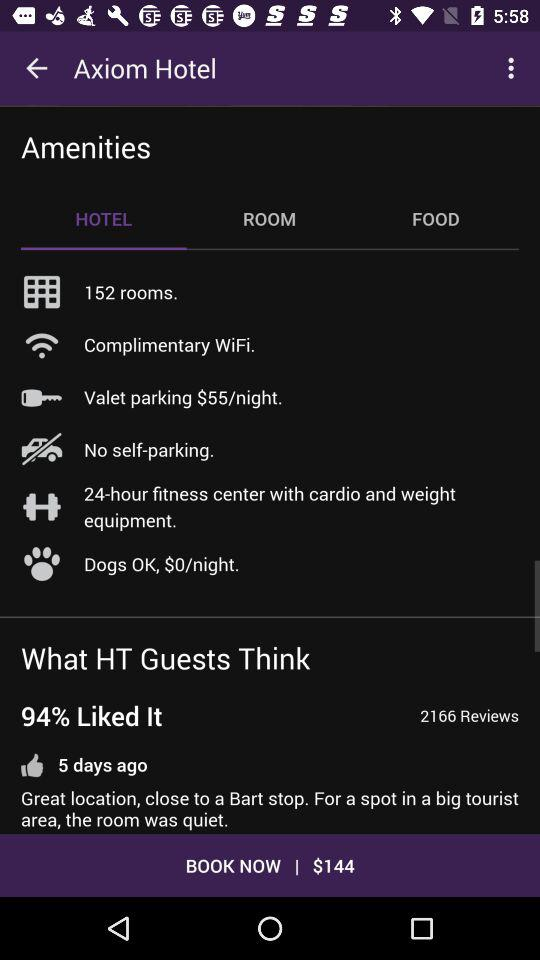How many reviews are there? There are 2166 reviews. 